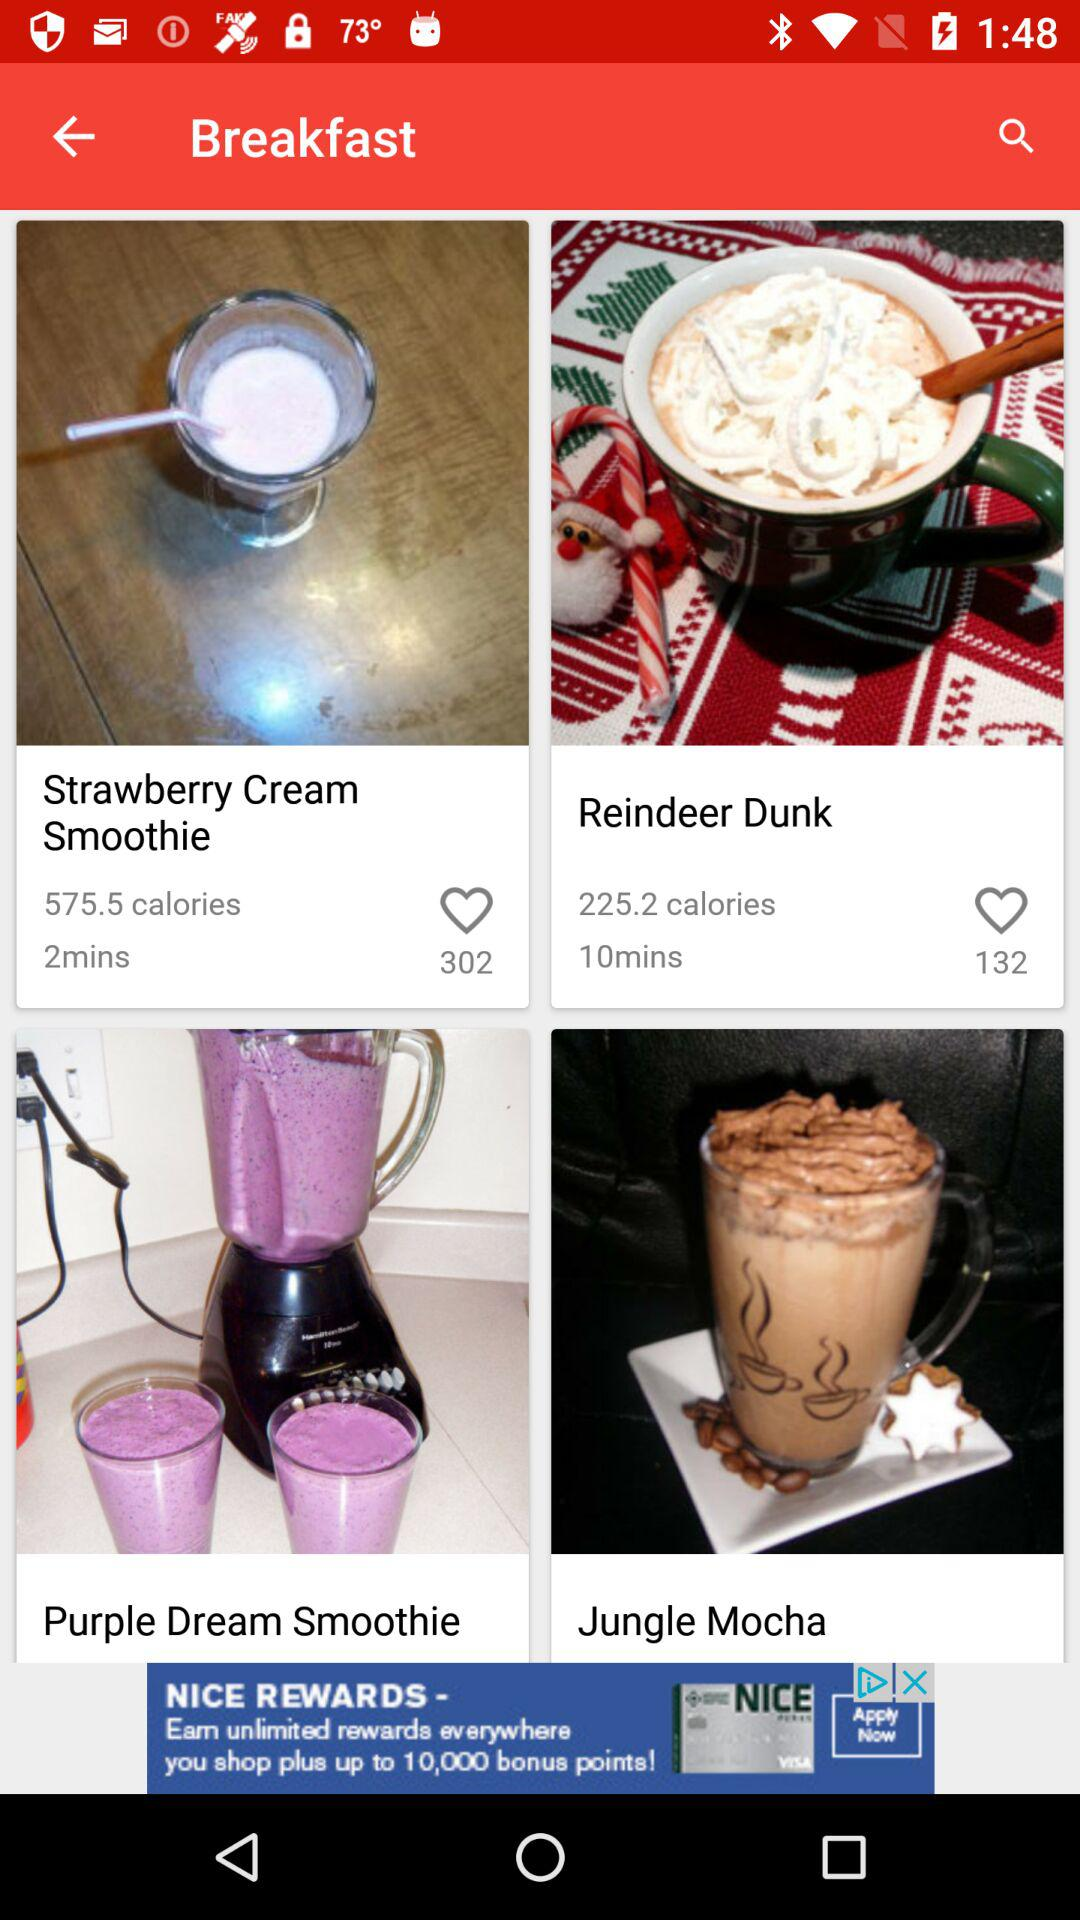What is the time given for "Reindeer Dunk"? The time given for "Reindeer Dunk" is 10 minutes. 